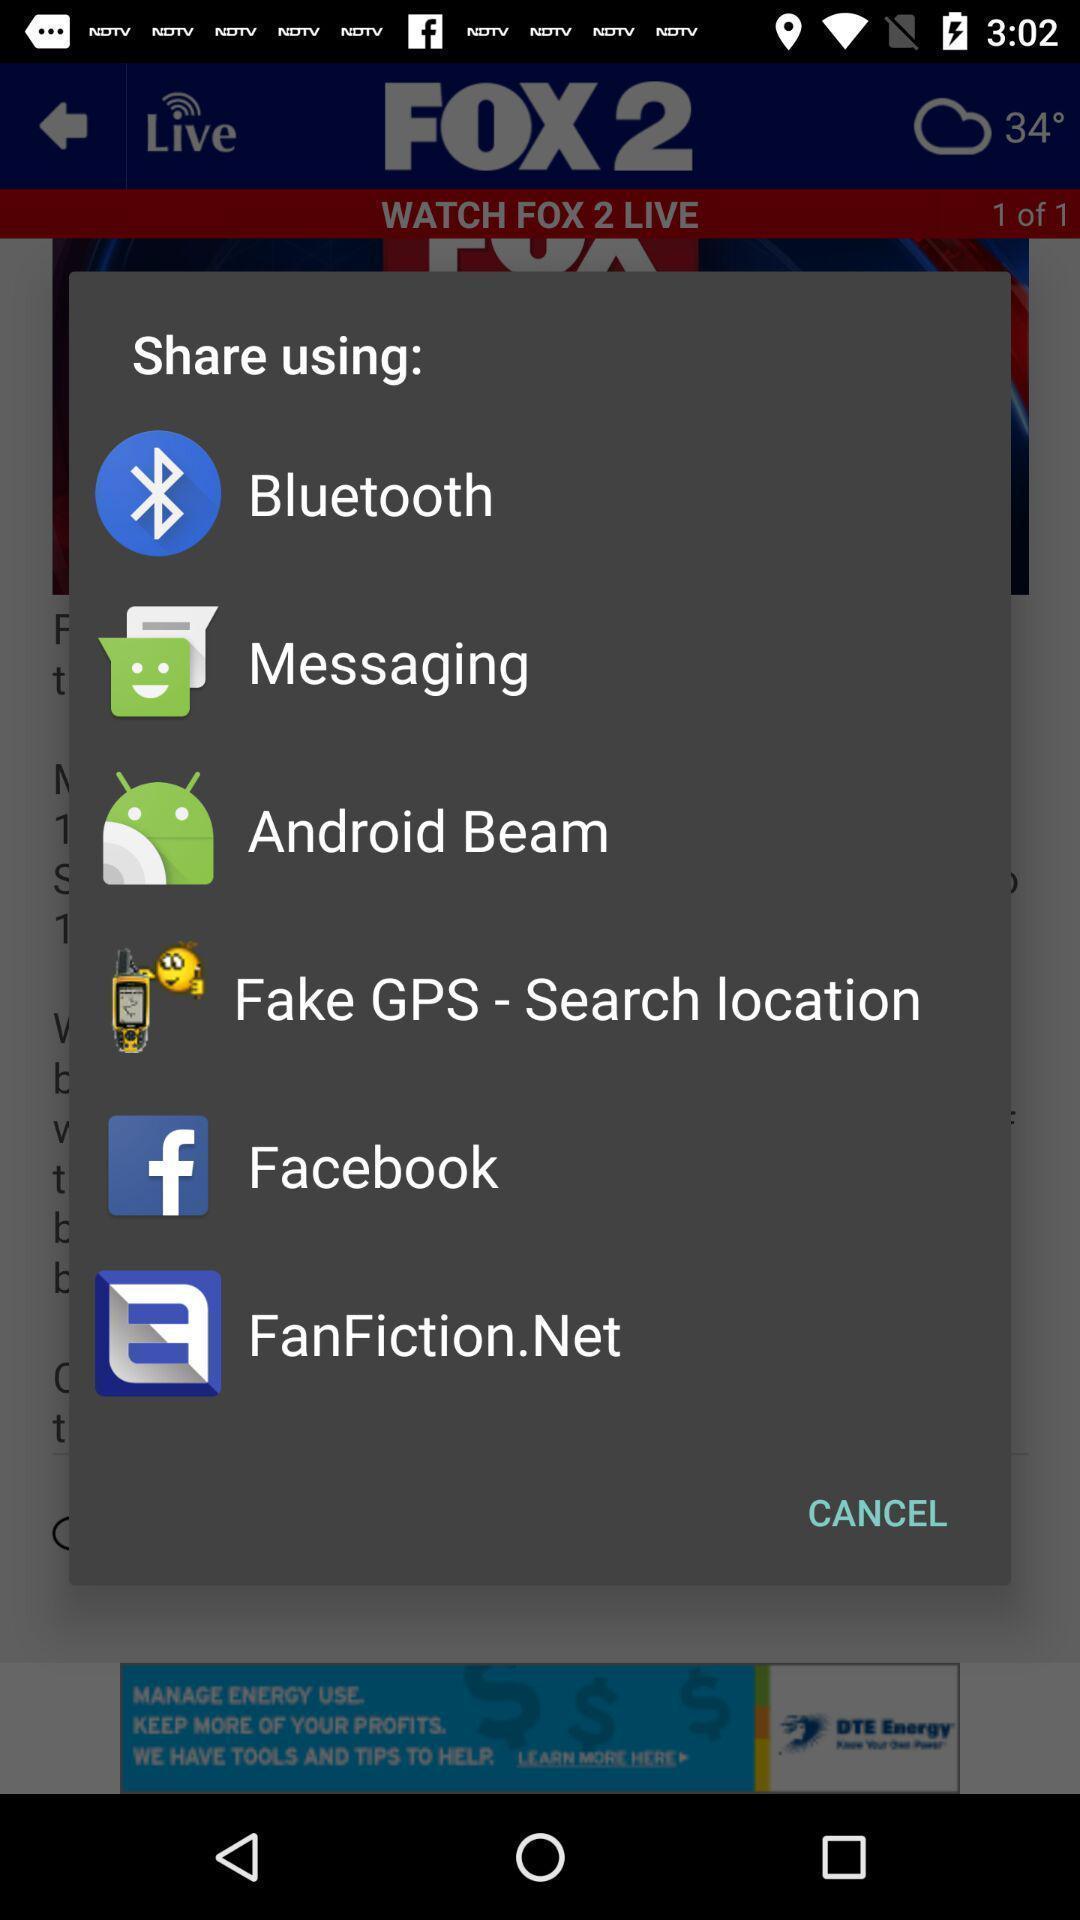Provide a textual representation of this image. Pop-up displaying apps to share data. 